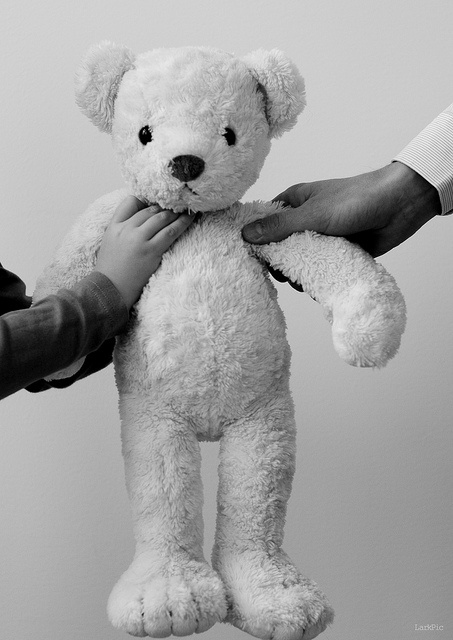Describe the objects in this image and their specific colors. I can see teddy bear in lightgray, darkgray, gray, and black tones, people in lightgray, black, gray, and darkgray tones, and people in lightgray, black, gray, and darkgray tones in this image. 